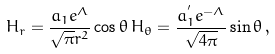<formula> <loc_0><loc_0><loc_500><loc_500>H _ { r } = \frac { a _ { 1 } e ^ { \Lambda } } { \sqrt { \pi } r ^ { 2 } } \cos \theta \, H _ { \theta } = \frac { a _ { 1 } ^ { ^ { \prime } } e ^ { - \Lambda } } { \sqrt { 4 \pi } } \sin \theta \, ,</formula> 